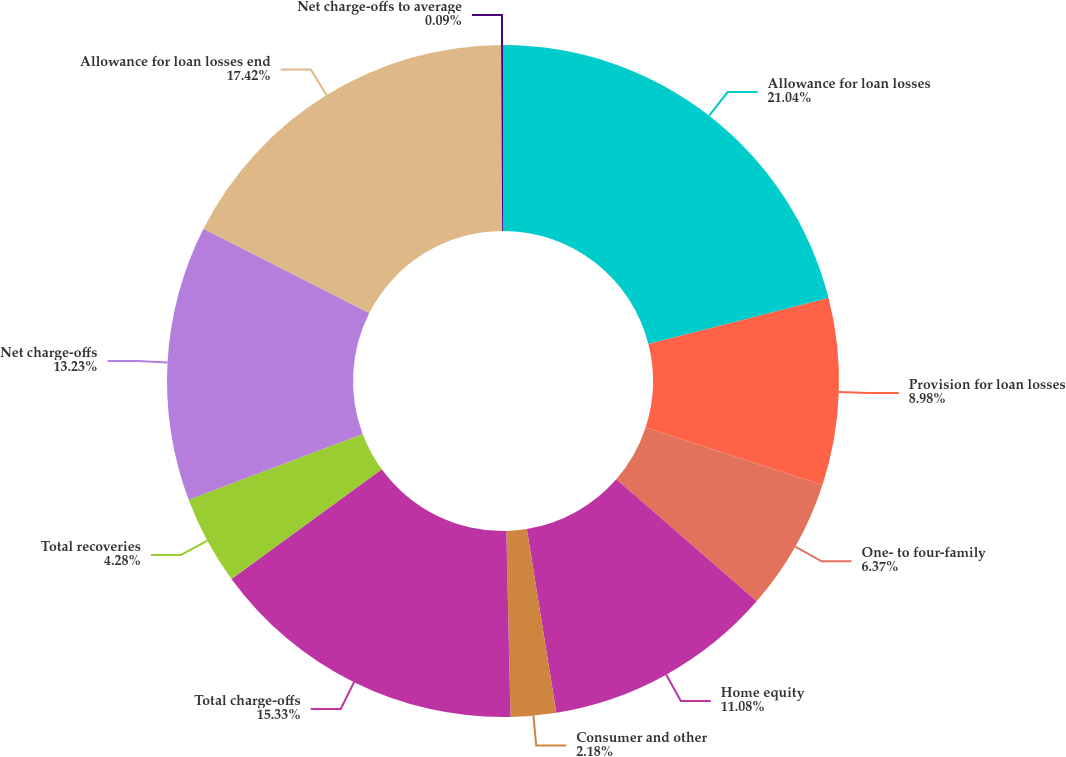<chart> <loc_0><loc_0><loc_500><loc_500><pie_chart><fcel>Allowance for loan losses<fcel>Provision for loan losses<fcel>One- to four-family<fcel>Home equity<fcel>Consumer and other<fcel>Total charge-offs<fcel>Total recoveries<fcel>Net charge-offs<fcel>Allowance for loan losses end<fcel>Net charge-offs to average<nl><fcel>21.03%<fcel>8.98%<fcel>6.37%<fcel>11.08%<fcel>2.18%<fcel>15.33%<fcel>4.28%<fcel>13.23%<fcel>17.42%<fcel>0.09%<nl></chart> 